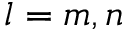Convert formula to latex. <formula><loc_0><loc_0><loc_500><loc_500>l = m , n</formula> 